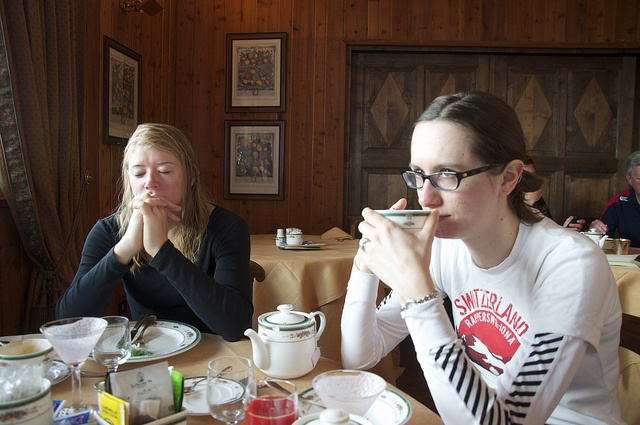Describe the objects in this image and their specific colors. I can see people in black, lightgray, darkgray, and gray tones, dining table in black, darkgray, lightgray, and gray tones, people in black, brown, lightgray, and maroon tones, dining table in black, maroon, tan, and gray tones, and chair in black, gray, tan, and olive tones in this image. 